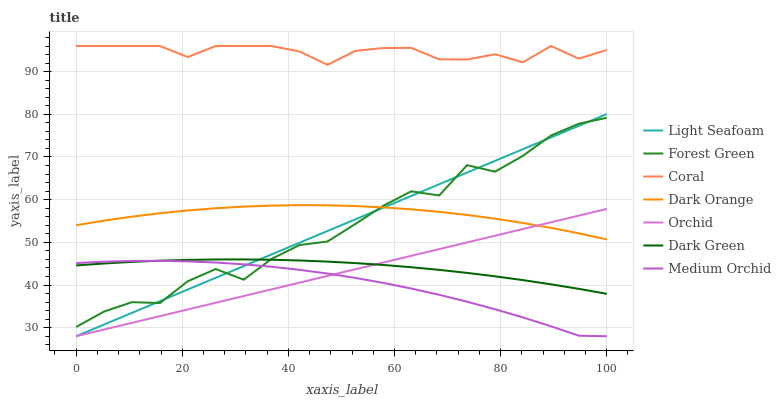Does Medium Orchid have the minimum area under the curve?
Answer yes or no. Yes. Does Coral have the maximum area under the curve?
Answer yes or no. Yes. Does Dark Orange have the minimum area under the curve?
Answer yes or no. No. Does Dark Orange have the maximum area under the curve?
Answer yes or no. No. Is Orchid the smoothest?
Answer yes or no. Yes. Is Forest Green the roughest?
Answer yes or no. Yes. Is Dark Orange the smoothest?
Answer yes or no. No. Is Dark Orange the roughest?
Answer yes or no. No. Does Orchid have the lowest value?
Answer yes or no. Yes. Does Dark Orange have the lowest value?
Answer yes or no. No. Does Coral have the highest value?
Answer yes or no. Yes. Does Dark Orange have the highest value?
Answer yes or no. No. Is Light Seafoam less than Coral?
Answer yes or no. Yes. Is Coral greater than Light Seafoam?
Answer yes or no. Yes. Does Dark Orange intersect Light Seafoam?
Answer yes or no. Yes. Is Dark Orange less than Light Seafoam?
Answer yes or no. No. Is Dark Orange greater than Light Seafoam?
Answer yes or no. No. Does Light Seafoam intersect Coral?
Answer yes or no. No. 